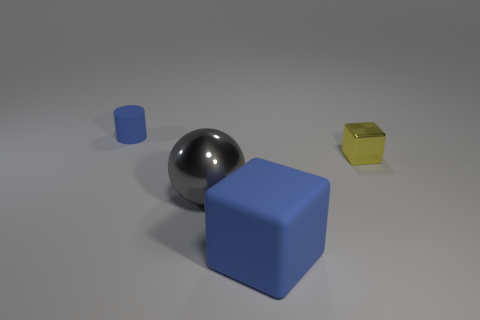If you had to use these objects in a practical setting, what might they be used for? In a practical sense, the large blue cube could serve as a sturdy base or seat, the sphere could be part of a decorative element or a tactile tool in sensory education, and the small yellow cube might be used as a paperweight or an aesthetically pleasing accent piece. 